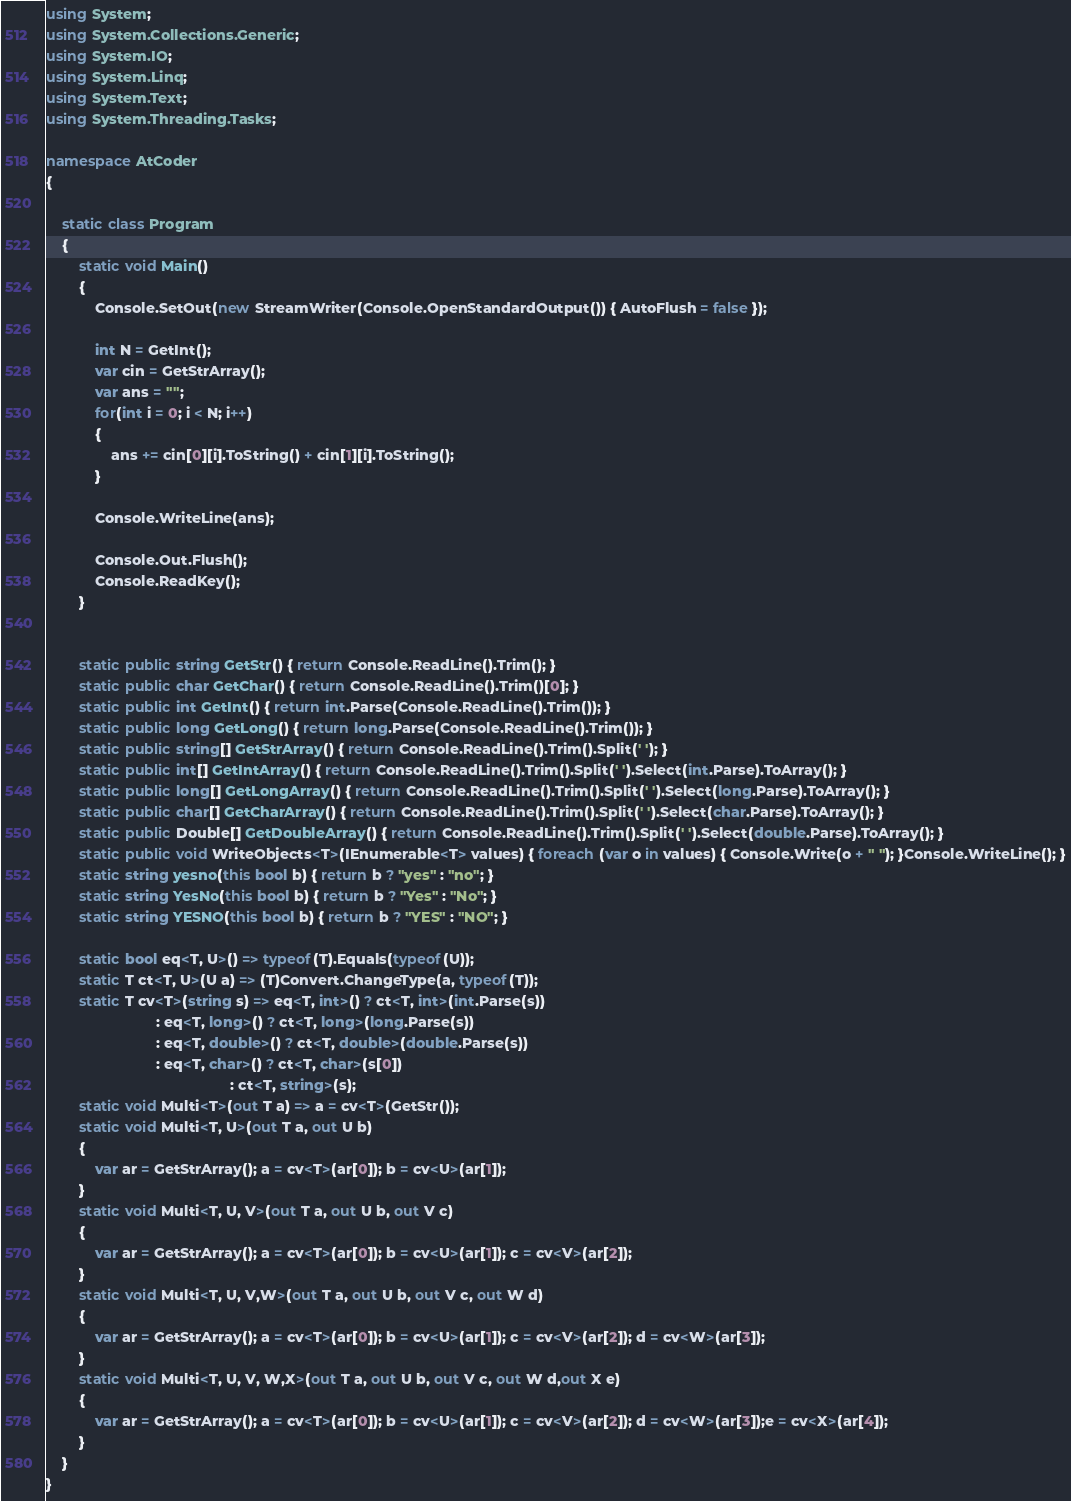Convert code to text. <code><loc_0><loc_0><loc_500><loc_500><_C#_>using System;
using System.Collections.Generic;
using System.IO;
using System.Linq;
using System.Text;
using System.Threading.Tasks;

namespace AtCoder
{

    static class Program
    {
        static void Main()
        {
            Console.SetOut(new StreamWriter(Console.OpenStandardOutput()) { AutoFlush = false });

            int N = GetInt();
            var cin = GetStrArray();
            var ans = "";
            for(int i = 0; i < N; i++)
            {
                ans += cin[0][i].ToString() + cin[1][i].ToString();
            }

            Console.WriteLine(ans);

            Console.Out.Flush();
            Console.ReadKey();
        }


        static public string GetStr() { return Console.ReadLine().Trim(); }
        static public char GetChar() { return Console.ReadLine().Trim()[0]; }
        static public int GetInt() { return int.Parse(Console.ReadLine().Trim()); }
        static public long GetLong() { return long.Parse(Console.ReadLine().Trim()); }
        static public string[] GetStrArray() { return Console.ReadLine().Trim().Split(' '); }
        static public int[] GetIntArray() { return Console.ReadLine().Trim().Split(' ').Select(int.Parse).ToArray(); }
        static public long[] GetLongArray() { return Console.ReadLine().Trim().Split(' ').Select(long.Parse).ToArray(); }
        static public char[] GetCharArray() { return Console.ReadLine().Trim().Split(' ').Select(char.Parse).ToArray(); }
        static public Double[] GetDoubleArray() { return Console.ReadLine().Trim().Split(' ').Select(double.Parse).ToArray(); }
        static public void WriteObjects<T>(IEnumerable<T> values) { foreach (var o in values) { Console.Write(o + " "); }Console.WriteLine(); }
        static string yesno(this bool b) { return b ? "yes" : "no"; }
        static string YesNo(this bool b) { return b ? "Yes" : "No"; }
        static string YESNO(this bool b) { return b ? "YES" : "NO"; }

        static bool eq<T, U>() => typeof(T).Equals(typeof(U));
        static T ct<T, U>(U a) => (T)Convert.ChangeType(a, typeof(T));
        static T cv<T>(string s) => eq<T, int>() ? ct<T, int>(int.Parse(s))
                           : eq<T, long>() ? ct<T, long>(long.Parse(s))
                           : eq<T, double>() ? ct<T, double>(double.Parse(s))
                           : eq<T, char>() ? ct<T, char>(s[0])
                                             : ct<T, string>(s);
        static void Multi<T>(out T a) => a = cv<T>(GetStr());
        static void Multi<T, U>(out T a, out U b)
        {
            var ar = GetStrArray(); a = cv<T>(ar[0]); b = cv<U>(ar[1]);
        }
        static void Multi<T, U, V>(out T a, out U b, out V c)
        {
            var ar = GetStrArray(); a = cv<T>(ar[0]); b = cv<U>(ar[1]); c = cv<V>(ar[2]);
        }
        static void Multi<T, U, V,W>(out T a, out U b, out V c, out W d)
        {
            var ar = GetStrArray(); a = cv<T>(ar[0]); b = cv<U>(ar[1]); c = cv<V>(ar[2]); d = cv<W>(ar[3]);
        }
        static void Multi<T, U, V, W,X>(out T a, out U b, out V c, out W d,out X e)
        {
            var ar = GetStrArray(); a = cv<T>(ar[0]); b = cv<U>(ar[1]); c = cv<V>(ar[2]); d = cv<W>(ar[3]);e = cv<X>(ar[4]);
        }
    }
}</code> 